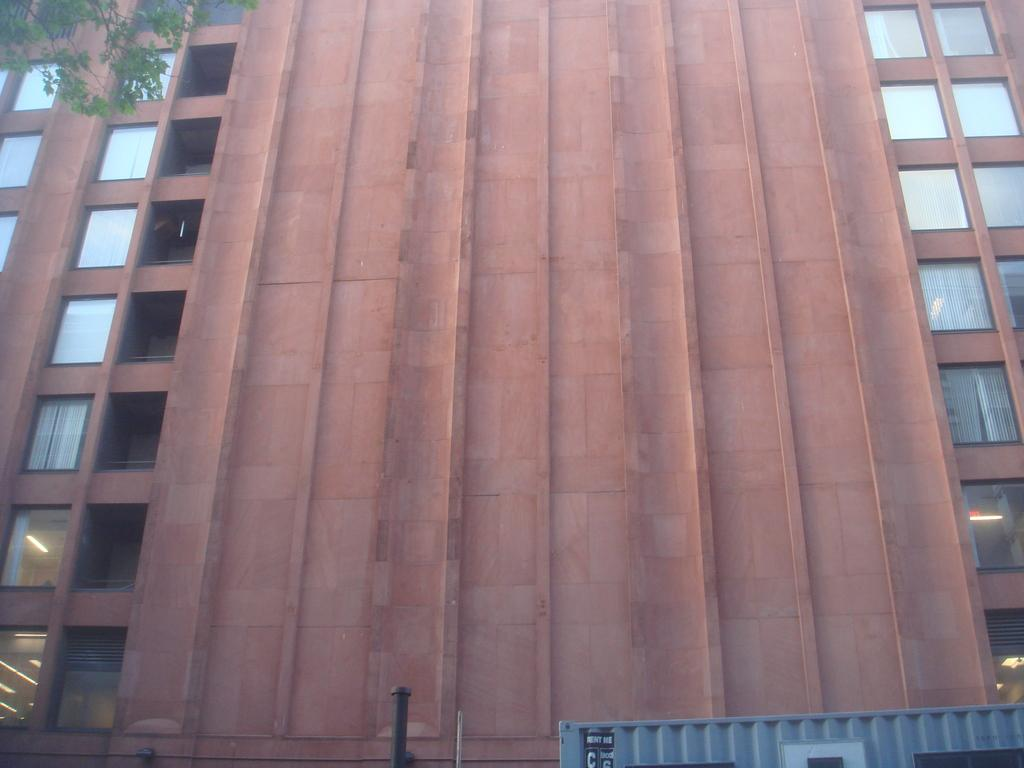What type of structure is present in the image? There is a building in the image. What is the color of the building? The building is brown in color. What other object can be seen in the image besides the building? There is a tree in the image. What is the color of the tree? The tree is green in color. Can you see the ocean in the image? No, there is no ocean present in the image. 